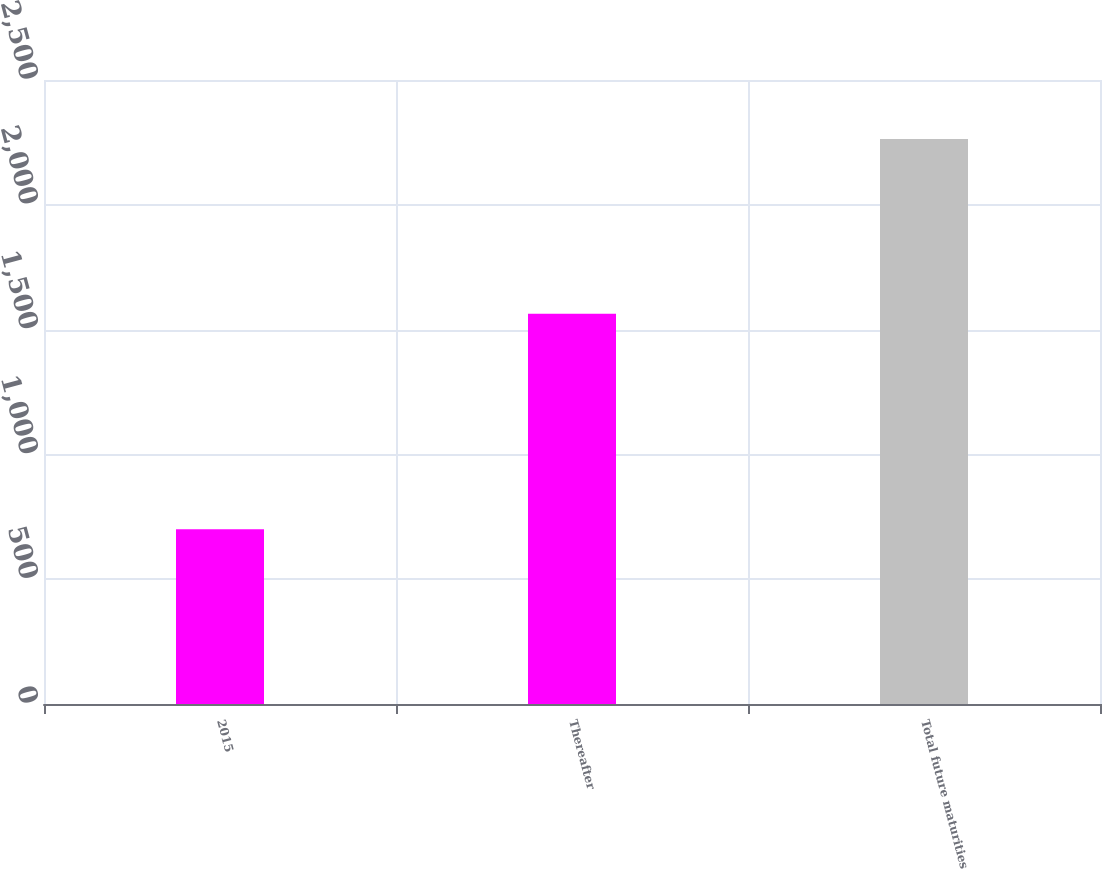Convert chart. <chart><loc_0><loc_0><loc_500><loc_500><bar_chart><fcel>2015<fcel>Thereafter<fcel>Total future maturities<nl><fcel>700<fcel>1564<fcel>2264<nl></chart> 